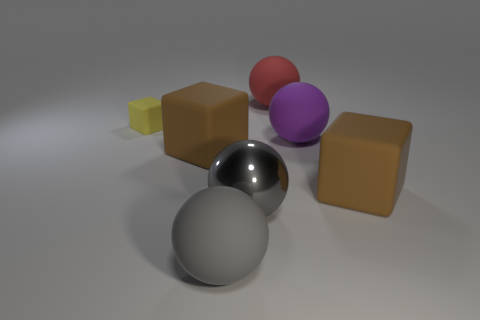Are there any other things that have the same color as the small matte thing?
Make the answer very short. No. What shape is the rubber thing that is both to the right of the big gray rubber sphere and behind the large purple thing?
Offer a terse response. Sphere. There is a matte thing that is behind the small yellow block; how big is it?
Give a very brief answer. Large. There is a rubber ball left of the matte ball that is behind the small matte thing; what number of red spheres are in front of it?
Give a very brief answer. 0. Are there any rubber cubes behind the red ball?
Give a very brief answer. No. What number of other objects are the same size as the red matte object?
Offer a very short reply. 5. What is the material of the large object that is both behind the large gray shiny sphere and left of the red matte thing?
Provide a succinct answer. Rubber. Do the gray rubber thing on the left side of the purple thing and the tiny yellow rubber object to the left of the red object have the same shape?
Ensure brevity in your answer.  No. Is there any other thing that is made of the same material as the large purple object?
Ensure brevity in your answer.  Yes. What is the shape of the brown thing that is to the right of the gray sphere behind the large gray rubber thing on the left side of the metallic sphere?
Your response must be concise. Cube. 